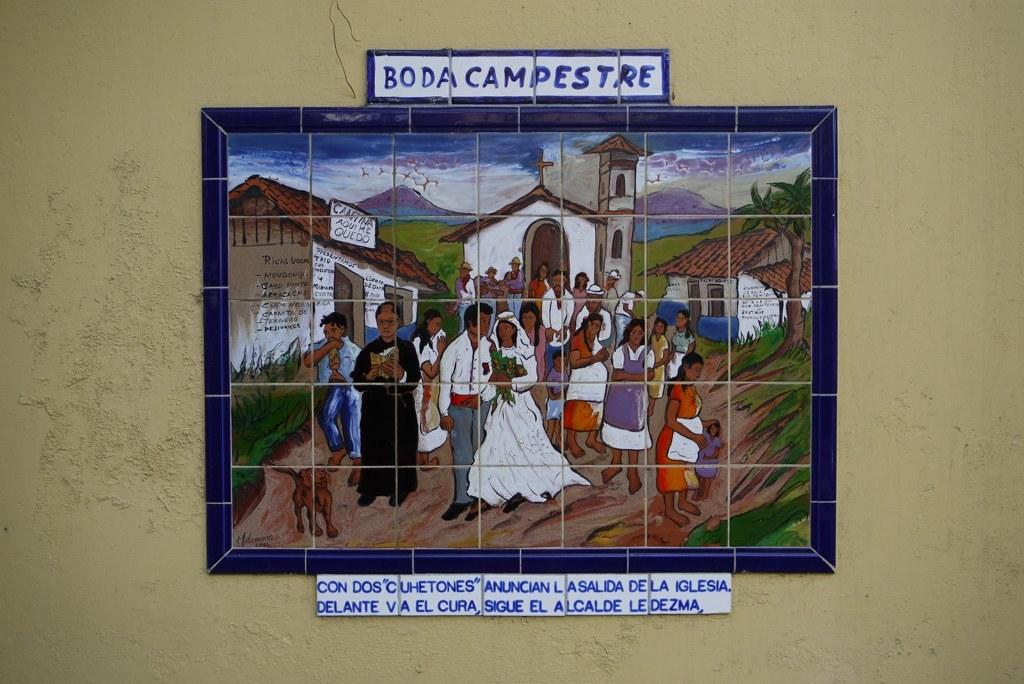<image>
Share a concise interpretation of the image provided. Painted tiles show people dressed for a wedding and it says Boda Campestre. 